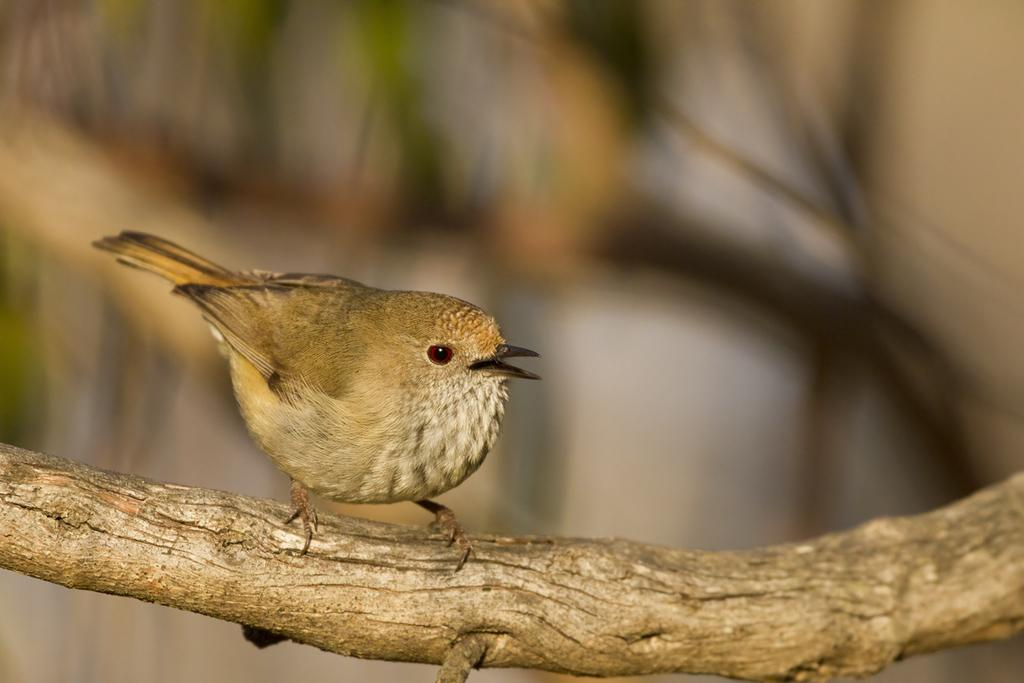What type of animal is in the image? There is a bird in the image. What is the bird standing on? The bird is on wood. Can you describe the background of the image? The background of the image is blurred. What type of net can be seen in the image? There is no net present in the image; it features a bird on wood with a blurred background. 